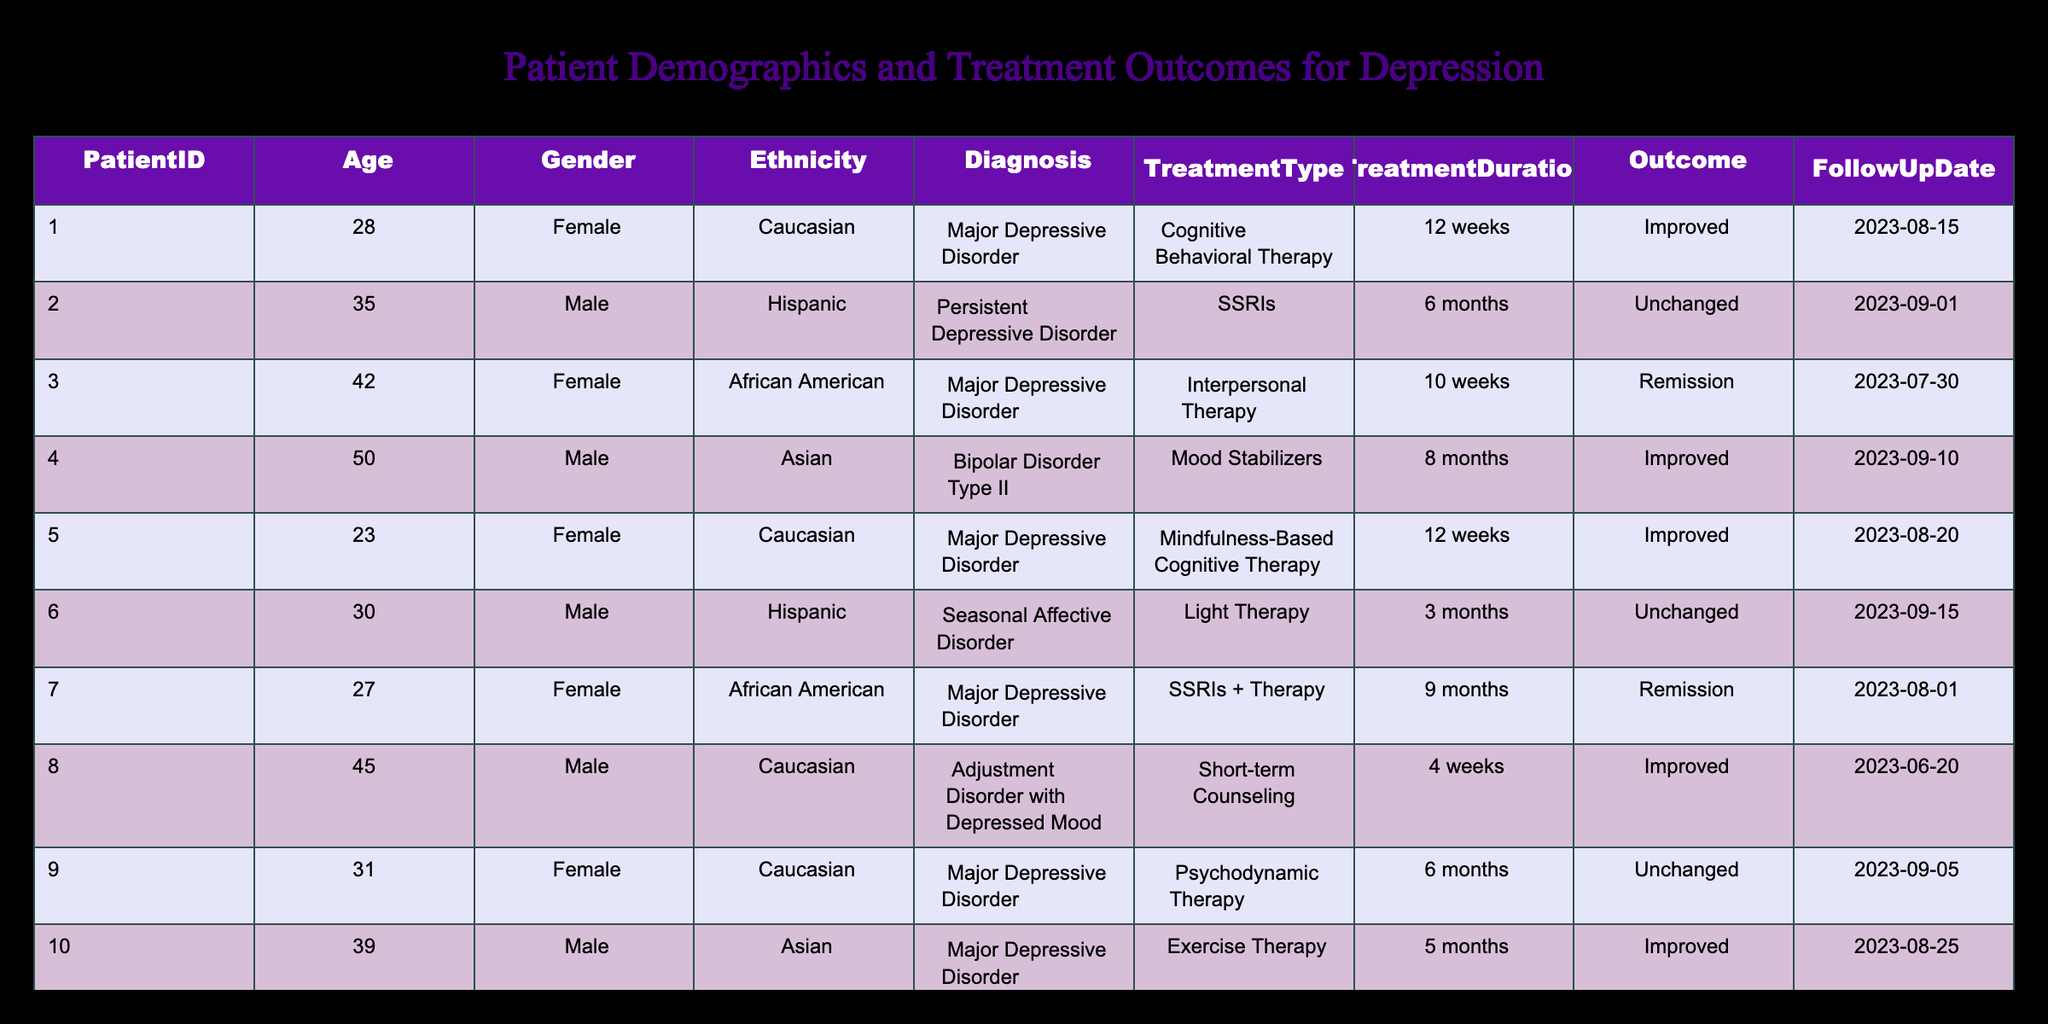What is the treatment type for PatientID 3? According to the table, PatientID 3 underwent Interpersonal Therapy. Simply refer to the TreatmentType column corresponding to PatientID 3.
Answer: Interpersonal Therapy How many patients had an outcome of "Improved"? By reviewing the Outcome column, there are four patients (PatientID 1, 4, 5, and 8) who achieved an outcome of "Improved." This requires counting the occurrences of "Improved" in that column.
Answer: 4 Is there any patient who underwent Exercise Therapy and had a follow-up outcome of "Remission"? Looking at the table, PatientID 10 underwent Exercise Therapy but had an outcome of "Improved," not "Remission." Therefore, the answer is based on checking these specific details.
Answer: No What is the average age of patients who experienced "Unchanged" outcomes? The patients with "Unchanged" outcomes are PatientID 2, 6, and 9. Their ages are 35, 30, and 31, respectively. Summing these gives 35 + 30 + 31 = 96, and dividing by 3 (the number of patients) yields an average of 32.
Answer: 32 Which gender has the highest representation among the patients with Major Depressive Disorder? The table shows that there are six patients diagnosed with Major Depressive Disorder, out of which four are female (PatientID 1, 3, 5, 7) and two are male (PatientID 2, 10). Since there are more females, the answer indicates which gender is predominant.
Answer: Female How many patients are of Hispanic ethnicity and what were their treatment types? Referring to the table, there are two patients of Hispanic ethnicity (PatientID 2 and 6). Their treatments were SSRIs and Light Therapy, respectively. This requires filtering the Ethnicity column and identifying the corresponding TreatmentType for each.
Answer: 2; SSRIs, Light Therapy Did any female patient achieve remission after treatment? Examining the table, PatientID 3 and PatientID 7 are both female and achieved remission after treatment. This is confirmed by checking the gender and outcome against the relevant patient IDs.
Answer: Yes What treatment duration did the patient with PatientID 4 undergo? By checking the TreatmentDuration column for PatientID 4, it shows that the treatment lasted for 8 months. This is a straightforward lookup in the table.
Answer: 8 months What is the total number of patients receiving Cognitive Behavioral Therapy and their outcomes? The only patient receiving Cognitive Behavioral Therapy is PatientID 1, who had an outcome of "Improved." This involves identifying the TreatmentType for patients and counting occurrences while checking outcomes.
Answer: 1; Improved 